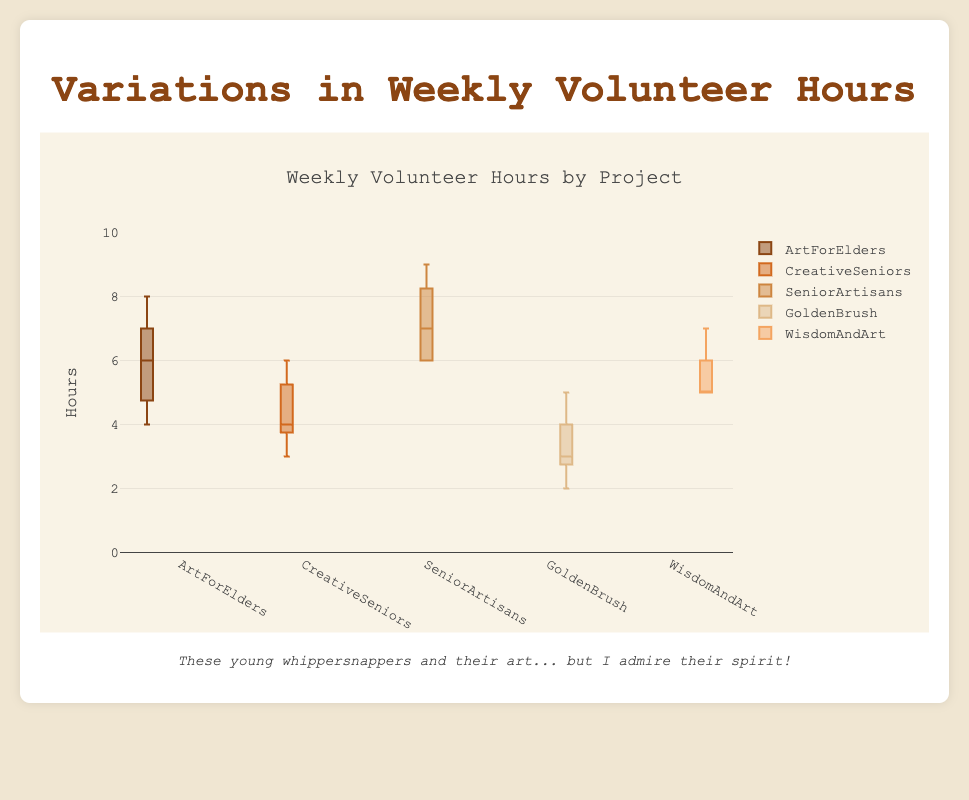How many community art projects are compared in this plot? There are five different community art projects being compared, as indicated by the five boxes labeled "ArtForElders," "CreativeSeniors," "SeniorArtisans," "GoldenBrush," and "WisdomAndArt."
Answer: 5 Which community art project has the highest median weekly volunteer hours? The median weekly volunteer hours for each project is indicated by the line inside the box. Among the projects, "SeniorArtisans" has the highest median line.
Answer: SeniorArtisans What is the range of volunteer hours for "GoldenBrush"? The range is the difference between the maximum and minimum values in the box plot. For "GoldenBrush," the minimum is 2 and the maximum is 5. So, the range is 5 - 2.
Answer: 3 Which project has the smallest variation in volunteer hours? The variation in the hours is reflected by the interquartile range (IQR), which is the width of the box. Narrower boxes indicate smaller variation. "WisdomAndArt" has the smallest box, indicating the least variation.
Answer: WisdomAndArt What's the first quartile (Q1) for "ArtForElders"? The first quartile is the bottom of the box. For "ArtForElders," this value appears to be 5 hours.
Answer: 5 Does "CreativeSeniors" have any outliers? If so, how many? Outliers are usually represented by individual points outside the whiskers on a box plot. "CreativeSeniors" has no individual points outside its whiskers, indicating no outliers.
Answer: No Compare the maximum weekly volunteer hours between "ArtForElders" and "GoldenBrush". The maximum value is the top end of the whisker. "ArtForElders" has a maximum of 8 hours, while "GoldenBrush" has a maximum of 5 hours.
Answer: ArtForElders has higher maximum hours (8 vs 5) What is the interquartile range (IQR) for "SeniorArtisans"? The IQR is the length of the box, calculated as Q3 - Q1. For "SeniorArtisans," Q1 is 6 and Q3 is 8. Thus, IQR = 8 - 6.
Answer: 2 Which project has the lowest minimum volunteer hours? The lowest minimum value is indicated by the bottom whisker. This is seen in "GoldenBrush," which has a minimum of 2 hours.
Answer: GoldenBrush Considering the spread and median, which project would you say has the most consistent volunteer hours? Consistency can be defined by small spread and median close to the central value of the range. "WisdomAndArt" has a small spread and the median is consistent with most hours centered around 5-6.
Answer: WisdomAndArt 